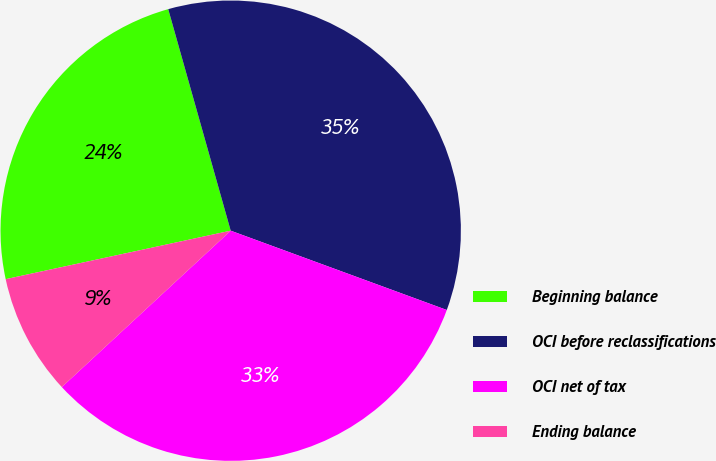Convert chart to OTSL. <chart><loc_0><loc_0><loc_500><loc_500><pie_chart><fcel>Beginning balance<fcel>OCI before reclassifications<fcel>OCI net of tax<fcel>Ending balance<nl><fcel>24.0%<fcel>34.97%<fcel>32.51%<fcel>8.51%<nl></chart> 